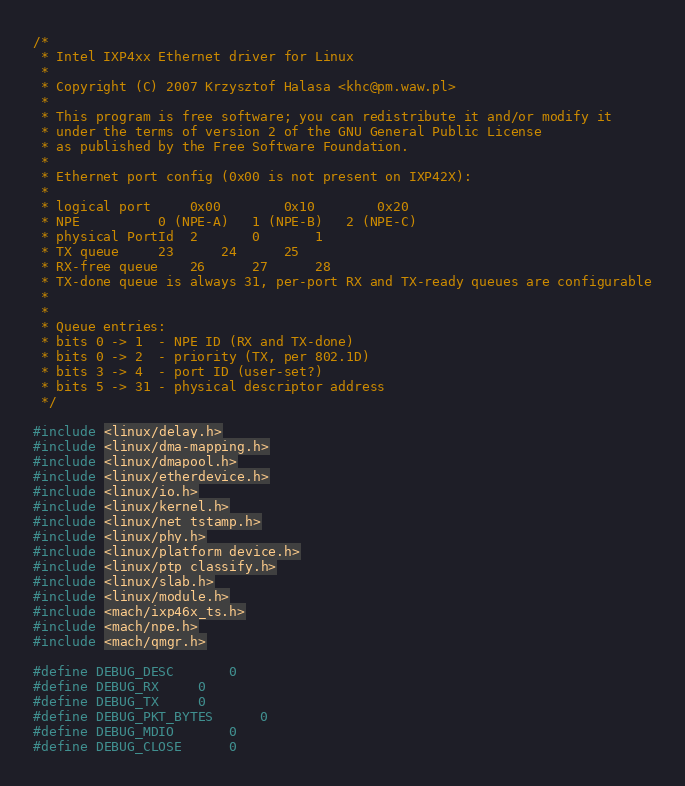<code> <loc_0><loc_0><loc_500><loc_500><_C_>/*
 * Intel IXP4xx Ethernet driver for Linux
 *
 * Copyright (C) 2007 Krzysztof Halasa <khc@pm.waw.pl>
 *
 * This program is free software; you can redistribute it and/or modify it
 * under the terms of version 2 of the GNU General Public License
 * as published by the Free Software Foundation.
 *
 * Ethernet port config (0x00 is not present on IXP42X):
 *
 * logical port		0x00		0x10		0x20
 * NPE			0 (NPE-A)	1 (NPE-B)	2 (NPE-C)
 * physical PortId	2		0		1
 * TX queue		23		24		25
 * RX-free queue	26		27		28
 * TX-done queue is always 31, per-port RX and TX-ready queues are configurable
 *
 *
 * Queue entries:
 * bits 0 -> 1	- NPE ID (RX and TX-done)
 * bits 0 -> 2	- priority (TX, per 802.1D)
 * bits 3 -> 4	- port ID (user-set?)
 * bits 5 -> 31	- physical descriptor address
 */

#include <linux/delay.h>
#include <linux/dma-mapping.h>
#include <linux/dmapool.h>
#include <linux/etherdevice.h>
#include <linux/io.h>
#include <linux/kernel.h>
#include <linux/net_tstamp.h>
#include <linux/phy.h>
#include <linux/platform_device.h>
#include <linux/ptp_classify.h>
#include <linux/slab.h>
#include <linux/module.h>
#include <mach/ixp46x_ts.h>
#include <mach/npe.h>
#include <mach/qmgr.h>

#define DEBUG_DESC		0
#define DEBUG_RX		0
#define DEBUG_TX		0
#define DEBUG_PKT_BYTES		0
#define DEBUG_MDIO		0
#define DEBUG_CLOSE		0
</code> 